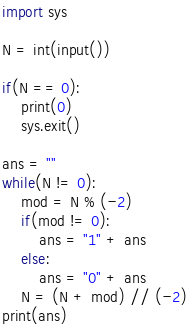<code> <loc_0><loc_0><loc_500><loc_500><_Python_>import sys

N = int(input())

if(N == 0):
    print(0)
    sys.exit()

ans = ""
while(N != 0):
    mod = N % (-2)
    if(mod != 0):
        ans = "1" + ans
    else:
        ans = "0" + ans
    N = (N + mod) // (-2)
print(ans)</code> 